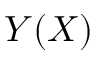<formula> <loc_0><loc_0><loc_500><loc_500>Y ( X )</formula> 